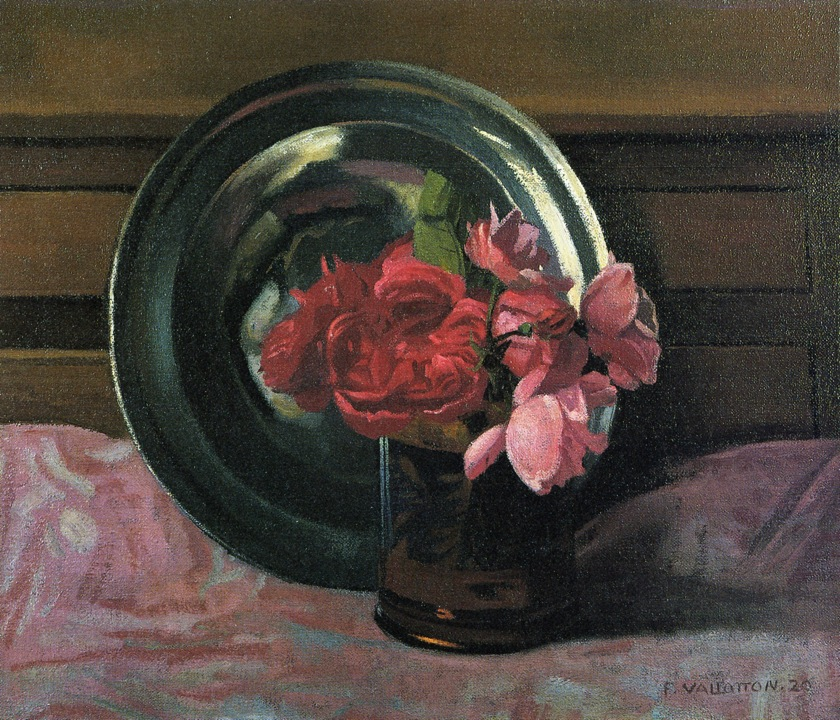Imagine the life story of the artist who painted this. What inspired them to create such a piece? The artist who painted this still-life was a dedicated realist painter, often inspired by the natural beauty and quiet elegance of everyday objects. Growing up in a modest countryside, the artist spent countless hours observing the delicate interplay of light and shadows on simple household items and garden flowers. Fascinated by the transient beauty of nature, the painter sought to capture these fleeting moments on canvas. The roses, possibly grown in the artist's own garden, symbolized a tender remembrance of a loved one or a period in the artist's life marked by beauty and grace. The choice of a muted palette for the background reflects the artist’s philosophical musings on the ephemeral nature of life, bringing a poignant depth and a timeless quality to the artwork. 